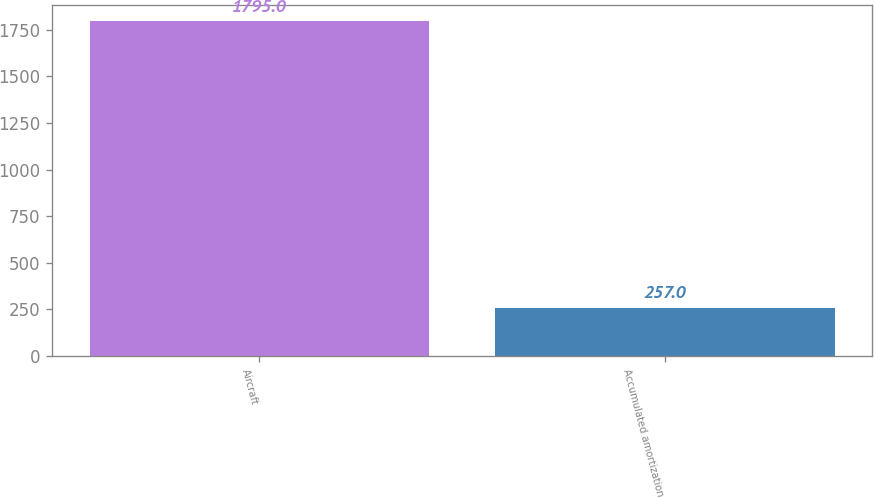Convert chart. <chart><loc_0><loc_0><loc_500><loc_500><bar_chart><fcel>Aircraft<fcel>Accumulated amortization<nl><fcel>1795<fcel>257<nl></chart> 